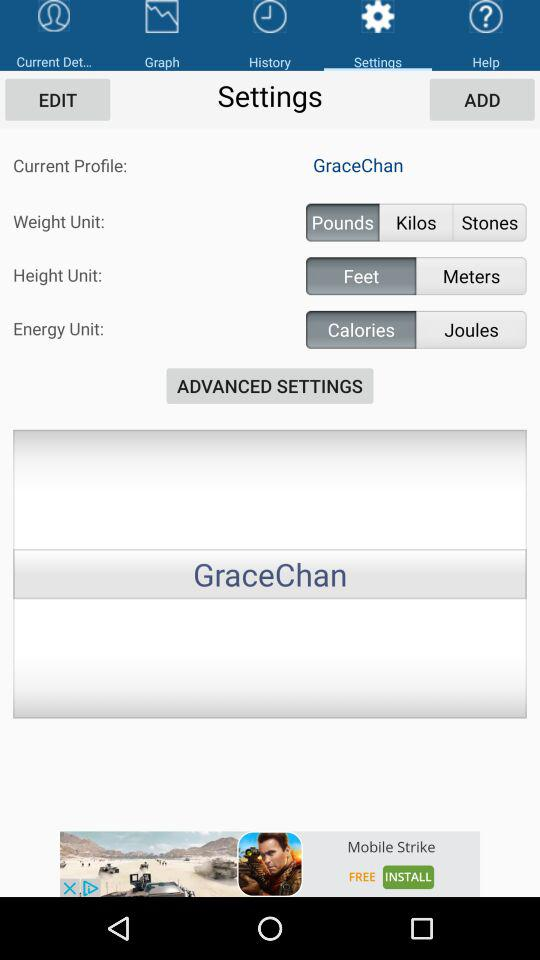How many weight units are available?
Answer the question using a single word or phrase. 3 